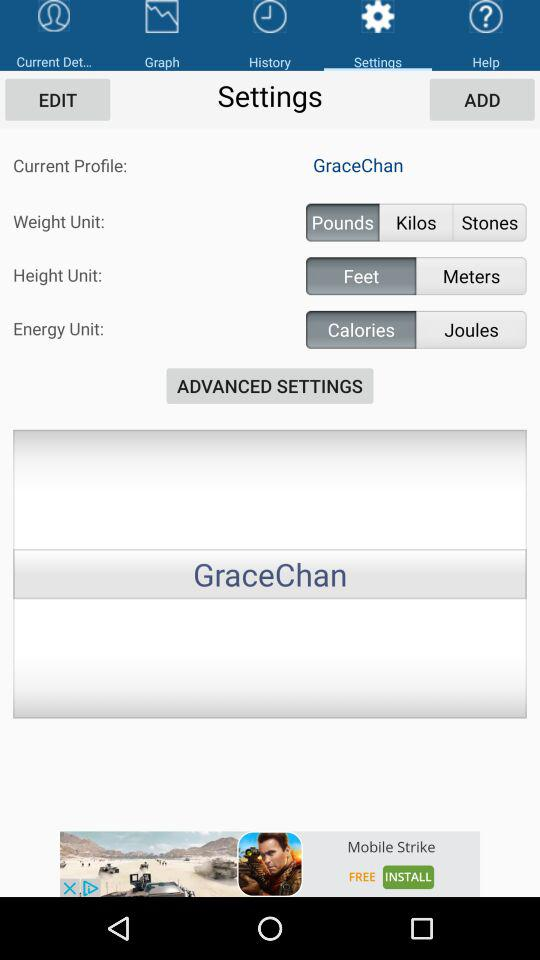How many weight units are available?
Answer the question using a single word or phrase. 3 